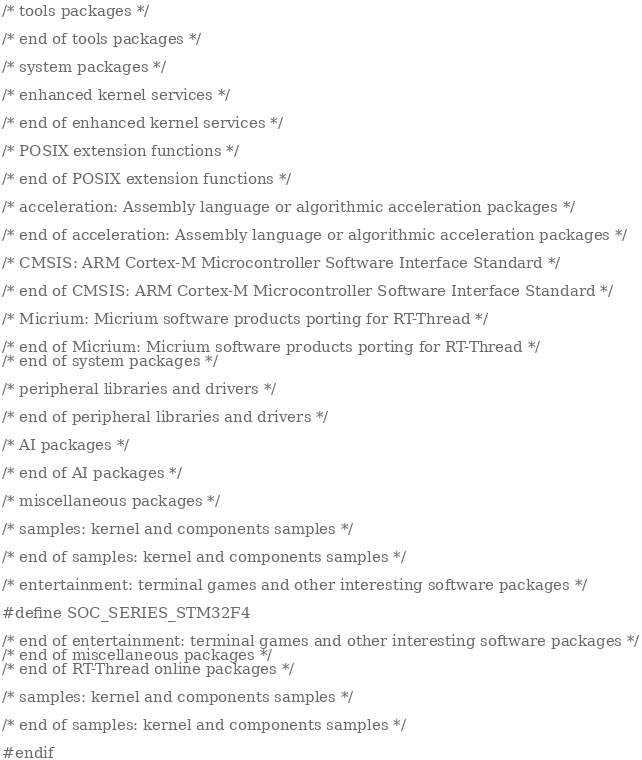Convert code to text. <code><loc_0><loc_0><loc_500><loc_500><_C_>
/* tools packages */

/* end of tools packages */

/* system packages */

/* enhanced kernel services */

/* end of enhanced kernel services */

/* POSIX extension functions */

/* end of POSIX extension functions */

/* acceleration: Assembly language or algorithmic acceleration packages */

/* end of acceleration: Assembly language or algorithmic acceleration packages */

/* CMSIS: ARM Cortex-M Microcontroller Software Interface Standard */

/* end of CMSIS: ARM Cortex-M Microcontroller Software Interface Standard */

/* Micrium: Micrium software products porting for RT-Thread */

/* end of Micrium: Micrium software products porting for RT-Thread */
/* end of system packages */

/* peripheral libraries and drivers */

/* end of peripheral libraries and drivers */

/* AI packages */

/* end of AI packages */

/* miscellaneous packages */

/* samples: kernel and components samples */

/* end of samples: kernel and components samples */

/* entertainment: terminal games and other interesting software packages */

#define SOC_SERIES_STM32F4

/* end of entertainment: terminal games and other interesting software packages */
/* end of miscellaneous packages */
/* end of RT-Thread online packages */

/* samples: kernel and components samples */

/* end of samples: kernel and components samples */

#endif
</code> 